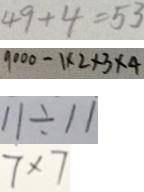<formula> <loc_0><loc_0><loc_500><loc_500>4 9 + 4 = 5 3 
 9 0 0 0 - 1 \times 2 \times 2 \times 3 \times 4 
 1 1 \div 1 1 
 7 \times 7</formula> 